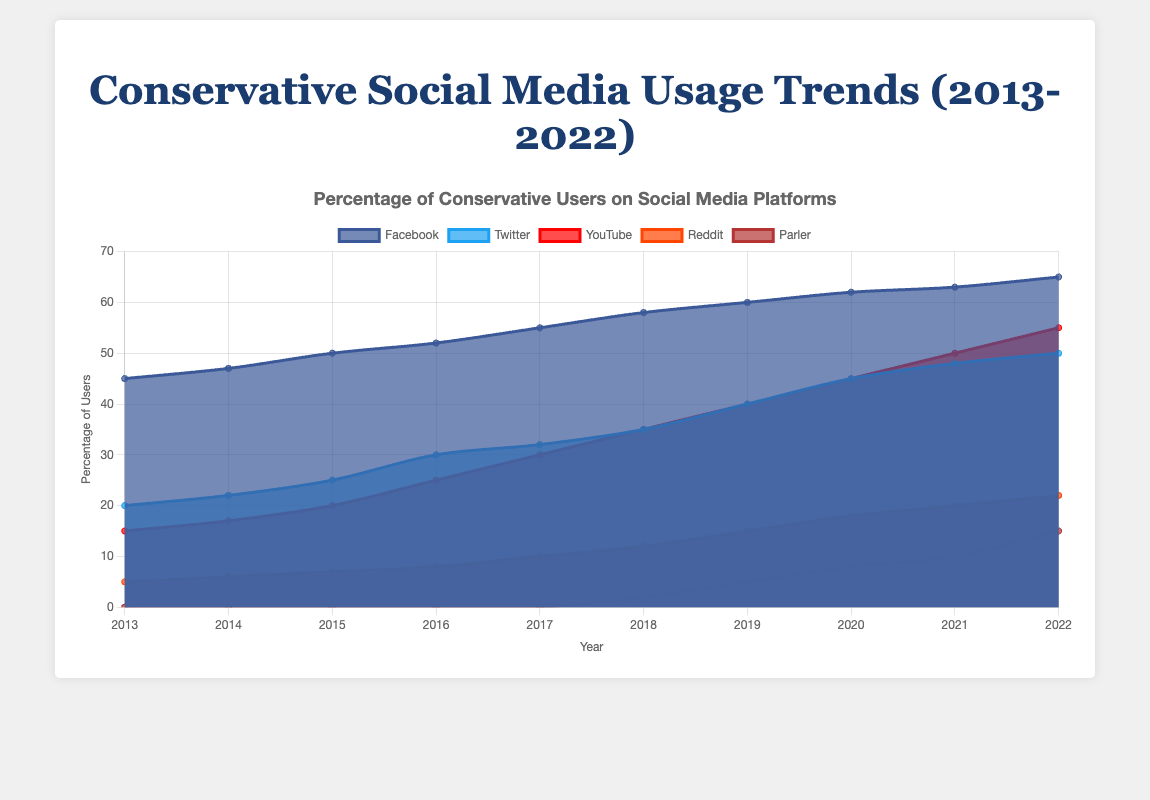what is the title of the chart? The title is usually located at the top of the chart and it reads "Conservative Social Media Usage Trends Among Conservatives Over the Past Decade".
Answer: Conservative Social Media Usage Trends Among Conservatives Over the Past Decade How many social media platforms are shown in the chart? The chart shows the trends for Facebook, Twitter, YouTube, Reddit, and Parler. We can count the distinct color areas representing each platform.
Answer: 5 What's the most popular social media platform among conservatives in 2022? By looking at the stack heights in 2022, Facebook has the highest value of 65%.
Answer: Facebook Can you identify the year when Parler first appeared in the data? Parler's trend starts at 2% in 2018, indicating its first appearance in that year.
Answer: 2018 How does the usage trend of YouTube compare to Facebook from 2013 to 2022? Facebook starts at 45% in 2013 and steadily increases to 65% in 2022. YouTube starts lower at 15% in 2013 but also increases, reaching 55% in 2022. Both show upward trends, but Facebook remains consistently higher.
Answer: Both increased, Facebook higher What percentage of conservatives used Twitter in 2019? Trace the line representing Twitter to the year 2019 and read the value, which is 40%.
Answer: 40% Which platform showed the most significant growth between 2018 and 2022? Calculate the difference for each platform:  
Facebook: 65% - 58% = 7%  
Twitter: 50% - 35% = 15%  
YouTube: 55% - 35% = 20%  
Reddit: 22% - 12% = 10%  
Parler: 15% - 2% = 13%  
YouTube has the highest increase (20%).
Answer: YouTube In which year did Reddit usage reach 20%? Track the trend for Reddit and find that it reaches 20% in 2021.
Answer: 2021 How do the trends for Facebook and Parler compare from 2018 to 2022? Facebook shows a steady increase from 58% to 65%, a 7% rise. Parler starts at 2% in 2018 and grows to 15% in 2022, a 13% rise. Parler's growth rate is higher, but their starting points differ significantly.
Answer: Steady increase for both, Parler's growth rate higher What's the combined percentage of usage for YouTube and Twitter in 2020? YouTube usage in 2020 is 45%, and Twitter usage is also 45%. Adding these two gives 45% + 45% = 90%.
Answer: 90% 